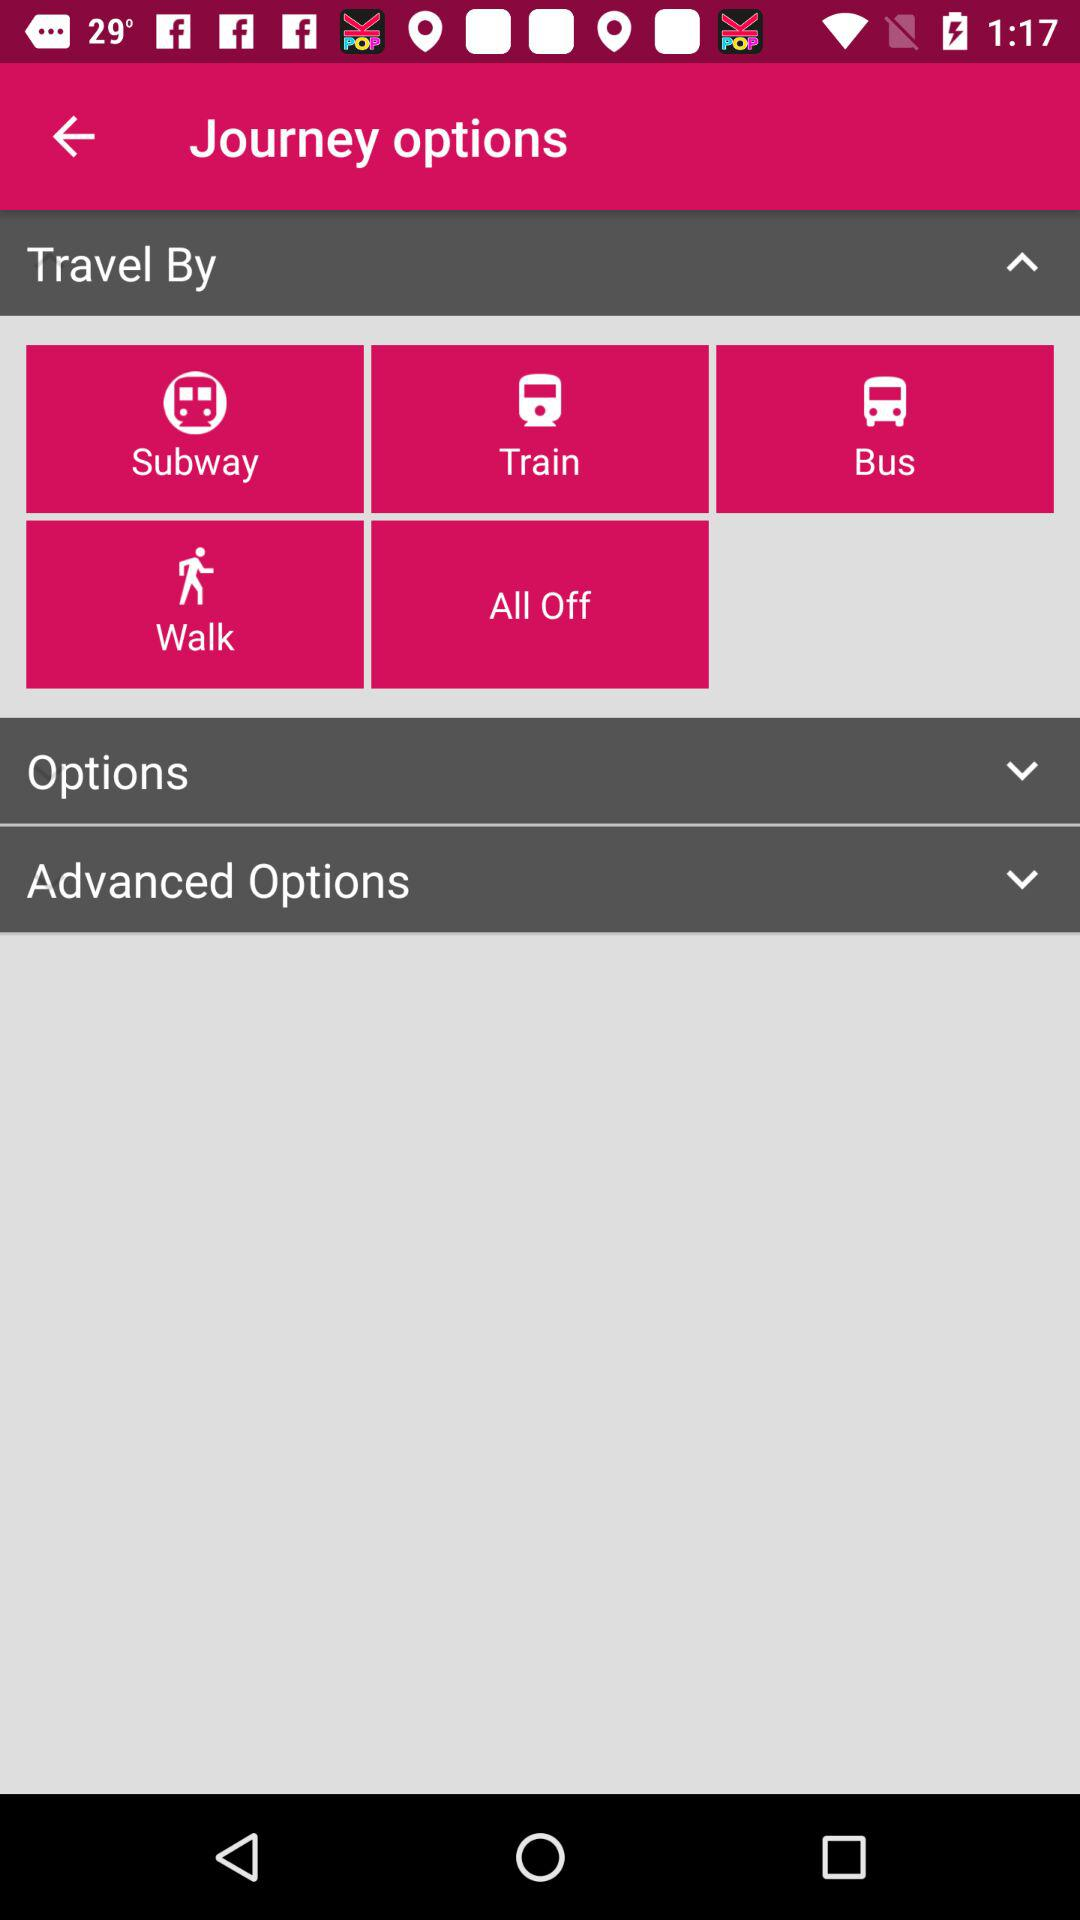What are the various available modes of transportation? The various available modes of transportation are "Subway", "Train", "Bus" and "Walk". 